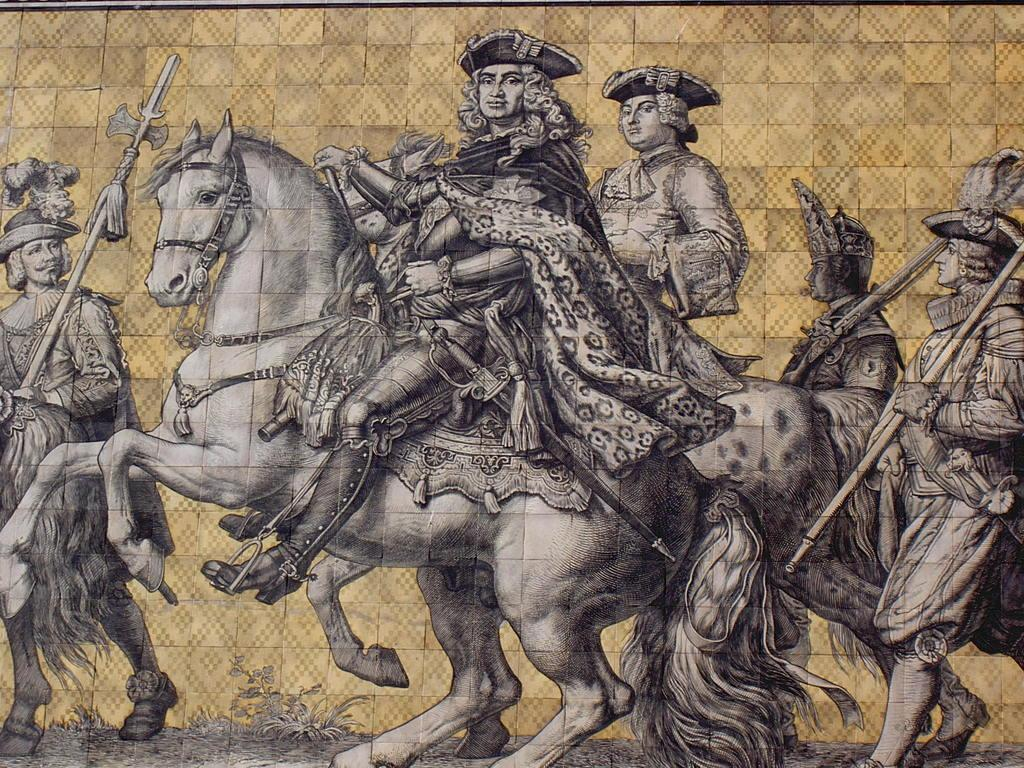What are the persons in the image doing? There are persons riding a horse and walking in the image. How many activities can be observed in the image? Two activities can be observed in the image: riding a horse and walking. How many goats are present in the image? There are no goats present in the image. What is the distance between the persons walking and the persons riding the horse? The provided facts do not give information about the distance between the persons, so it cannot be determined from the image. 